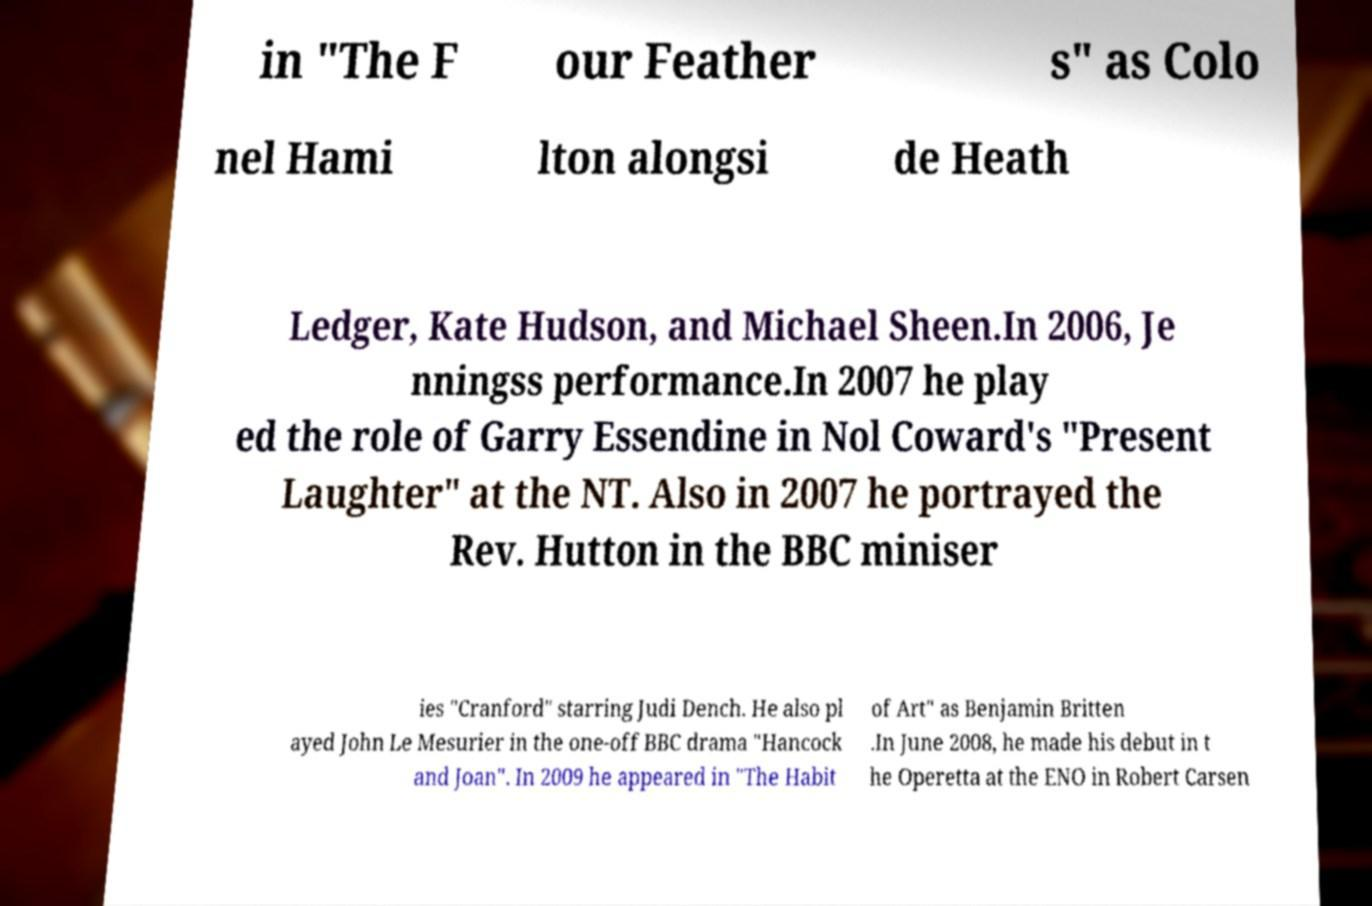Could you extract and type out the text from this image? in "The F our Feather s" as Colo nel Hami lton alongsi de Heath Ledger, Kate Hudson, and Michael Sheen.In 2006, Je nningss performance.In 2007 he play ed the role of Garry Essendine in Nol Coward's "Present Laughter" at the NT. Also in 2007 he portrayed the Rev. Hutton in the BBC miniser ies "Cranford" starring Judi Dench. He also pl ayed John Le Mesurier in the one-off BBC drama "Hancock and Joan". In 2009 he appeared in "The Habit of Art" as Benjamin Britten .In June 2008, he made his debut in t he Operetta at the ENO in Robert Carsen 